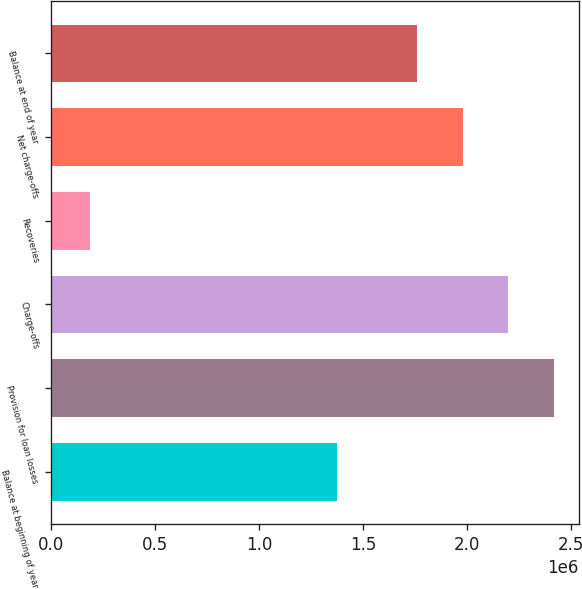<chart> <loc_0><loc_0><loc_500><loc_500><bar_chart><fcel>Balance at beginning of year<fcel>Provision for loan losses<fcel>Charge-offs<fcel>Recoveries<fcel>Net charge-offs<fcel>Balance at end of year<nl><fcel>1.37458e+06<fcel>2.41426e+06<fcel>2.19668e+06<fcel>186562<fcel>1.97909e+06<fcel>1.7579e+06<nl></chart> 